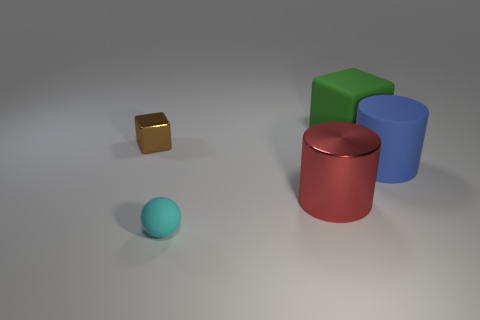Add 3 small brown rubber spheres. How many objects exist? 8 Subtract all balls. How many objects are left? 4 Subtract all cyan rubber spheres. Subtract all blue matte objects. How many objects are left? 3 Add 2 red shiny cylinders. How many red shiny cylinders are left? 3 Add 1 gray metal cubes. How many gray metal cubes exist? 1 Subtract 0 gray cubes. How many objects are left? 5 